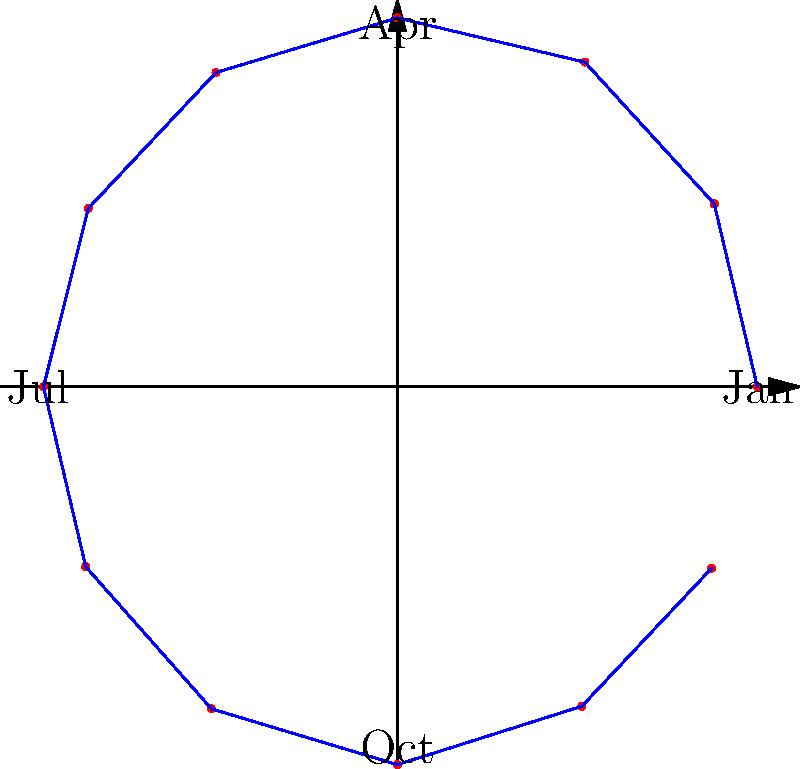In the polar plot above, which represents the EUR/USD exchange rate over a year, what does the pattern suggest about the currency pair's volatility during the summer months (June to August) compared to the rest of the year? To answer this question, let's analyze the polar plot step-by-step:

1. The plot represents the EUR/USD exchange rate over a year, with each point corresponding to a month.
2. The distance from the center represents the exchange rate value, while the angle represents the time of year.
3. The months are arranged clockwise, starting with January at the right (3 o'clock position) and progressing through the year.
4. Summer months (June to August) correspond roughly to the left side of the plot.
5. Observing the left side of the plot:
   - The line segments are shorter and closer to each other.
   - There's less variation in the radial distance from the center.
6. Comparing to other parts of the plot:
   - The right side (winter months) shows longer line segments and more variation in radial distance.
   - The top and bottom (spring and fall) also show more pronounced changes in radial distance.
7. Shorter line segments and less radial variation indicate smaller changes in the exchange rate from month to month.
8. This pattern suggests that the EUR/USD exchange rate was less volatile (more stable) during the summer months compared to the rest of the year.

Therefore, the polar plot indicates lower volatility in the EUR/USD exchange rate during the summer months compared to other seasons.
Answer: Lower volatility in summer months 